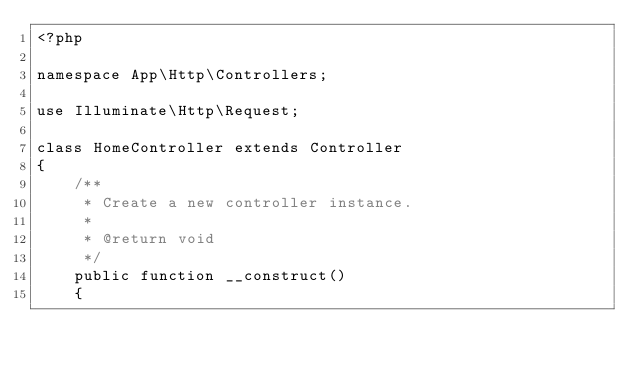<code> <loc_0><loc_0><loc_500><loc_500><_PHP_><?php

namespace App\Http\Controllers;

use Illuminate\Http\Request;

class HomeController extends Controller
{
    /**
     * Create a new controller instance.
     *
     * @return void
     */
    public function __construct()
    {</code> 